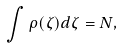Convert formula to latex. <formula><loc_0><loc_0><loc_500><loc_500>\int \rho ( \zeta ) d \zeta = N ,</formula> 